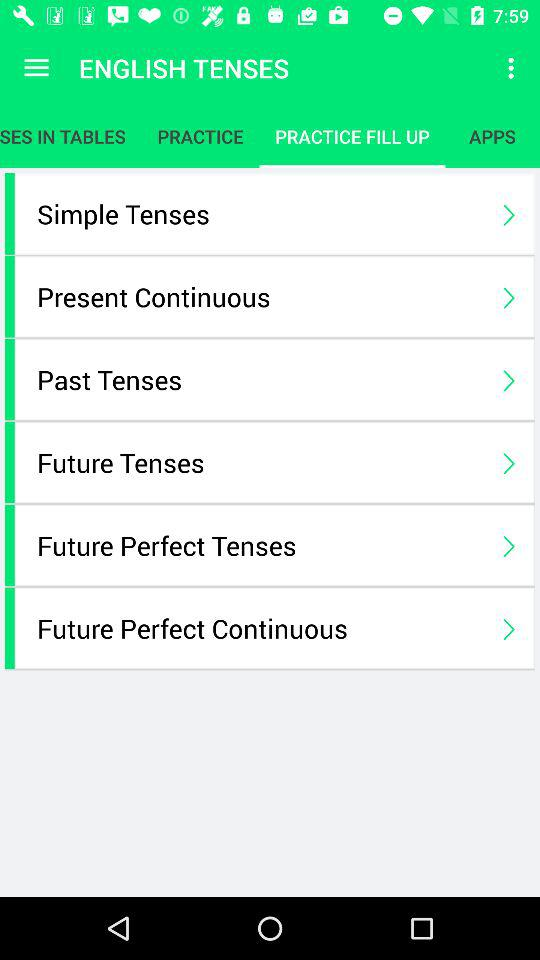How many tenses are there in total?
Answer the question using a single word or phrase. 6 